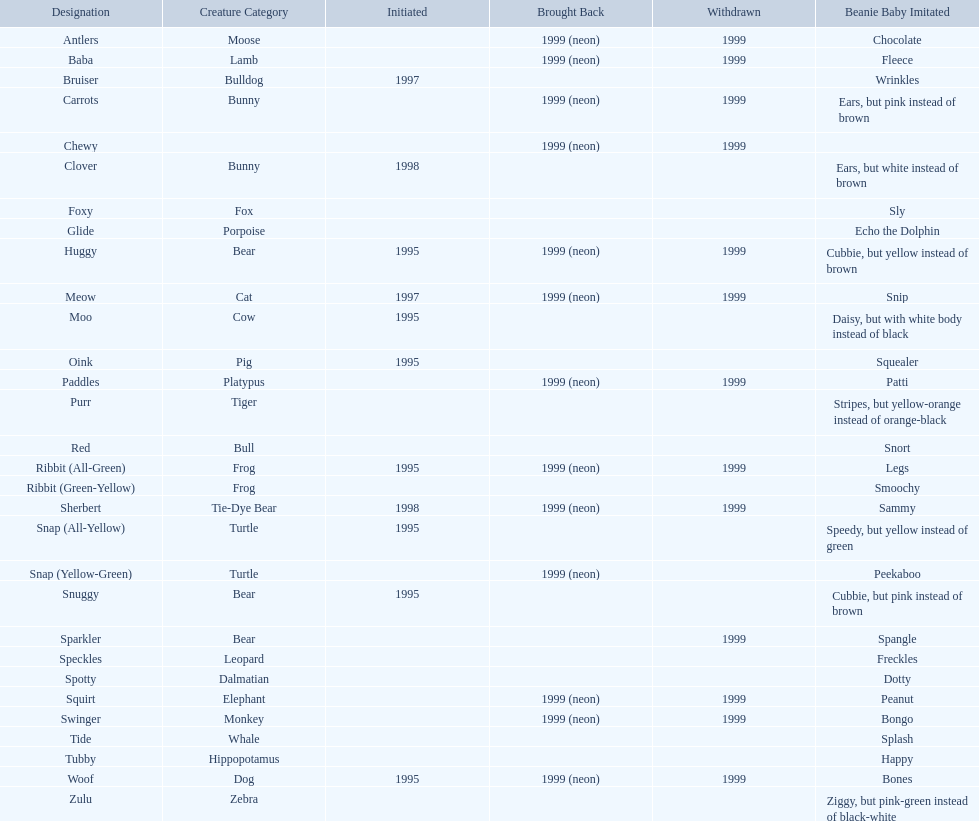What animals are pillow pals? Moose, Lamb, Bulldog, Bunny, Bunny, Fox, Porpoise, Bear, Cat, Cow, Pig, Platypus, Tiger, Bull, Frog, Frog, Tie-Dye Bear, Turtle, Turtle, Bear, Bear, Leopard, Dalmatian, Elephant, Monkey, Whale, Hippopotamus, Dog, Zebra. What is the name of the dalmatian? Spotty. 